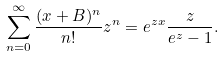Convert formula to latex. <formula><loc_0><loc_0><loc_500><loc_500>\sum _ { n = 0 } ^ { \infty } \frac { ( x + B ) ^ { n } } { n ! } z ^ { n } = e ^ { z x } \frac { z } { e ^ { z } - 1 } .</formula> 